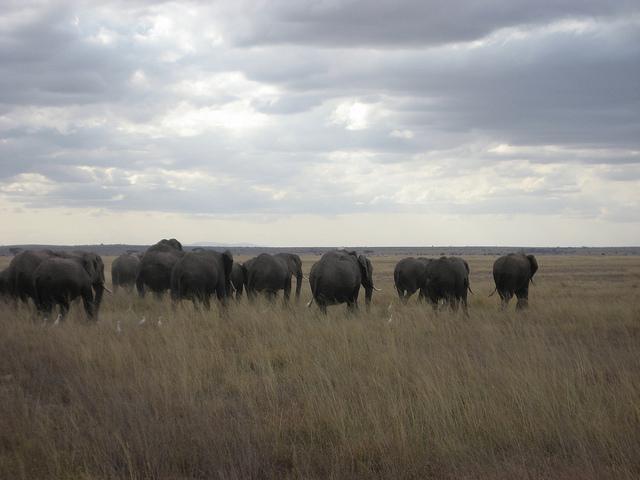How many elephants are visible?
Give a very brief answer. 6. 